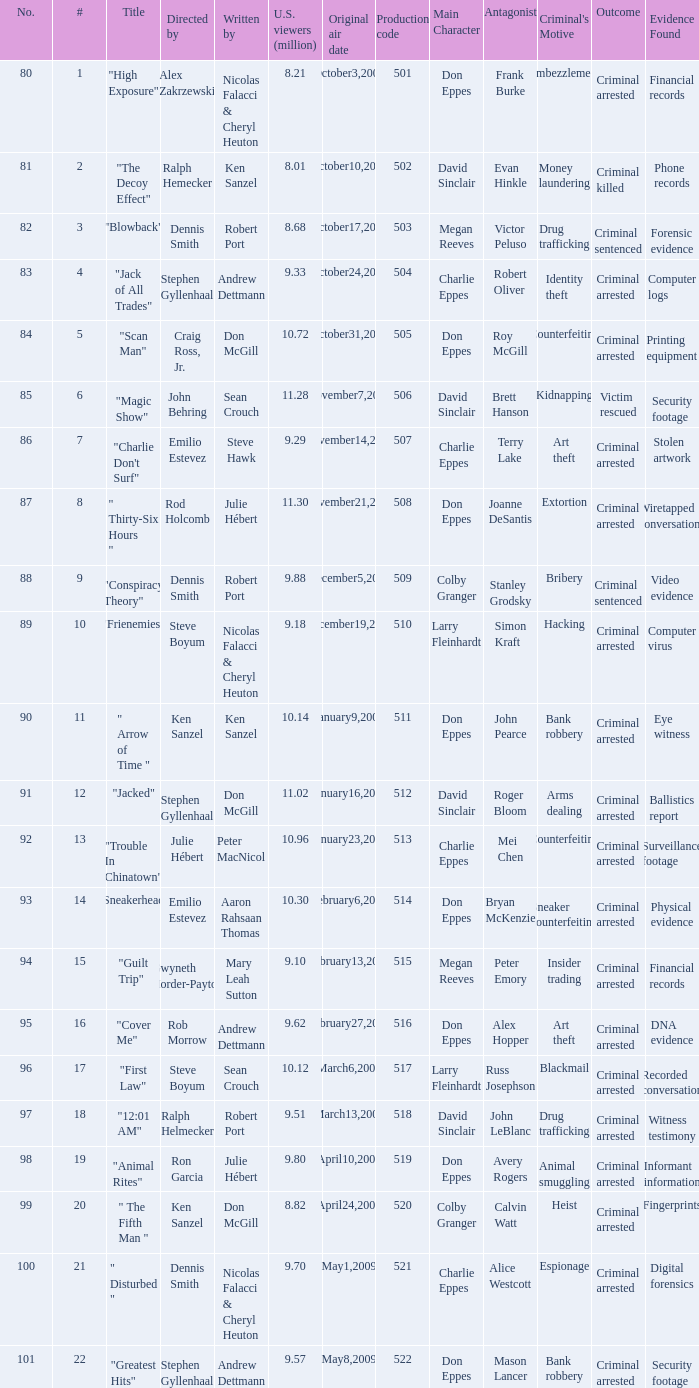What episode had 10.14 million viewers (U.S.)? 11.0. 